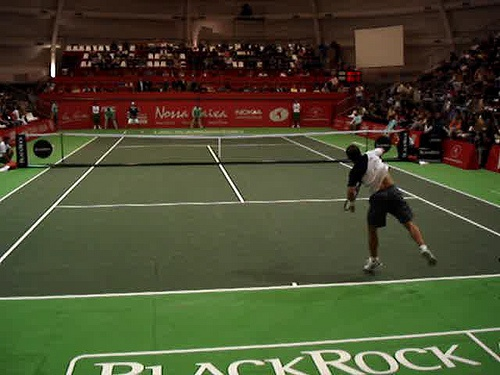Describe the objects in this image and their specific colors. I can see people in black, maroon, and gray tones, people in black, gray, and darkgray tones, chair in black, maroon, and gray tones, people in black, gray, darkgreen, and darkgray tones, and people in black, gray, maroon, and darkgray tones in this image. 